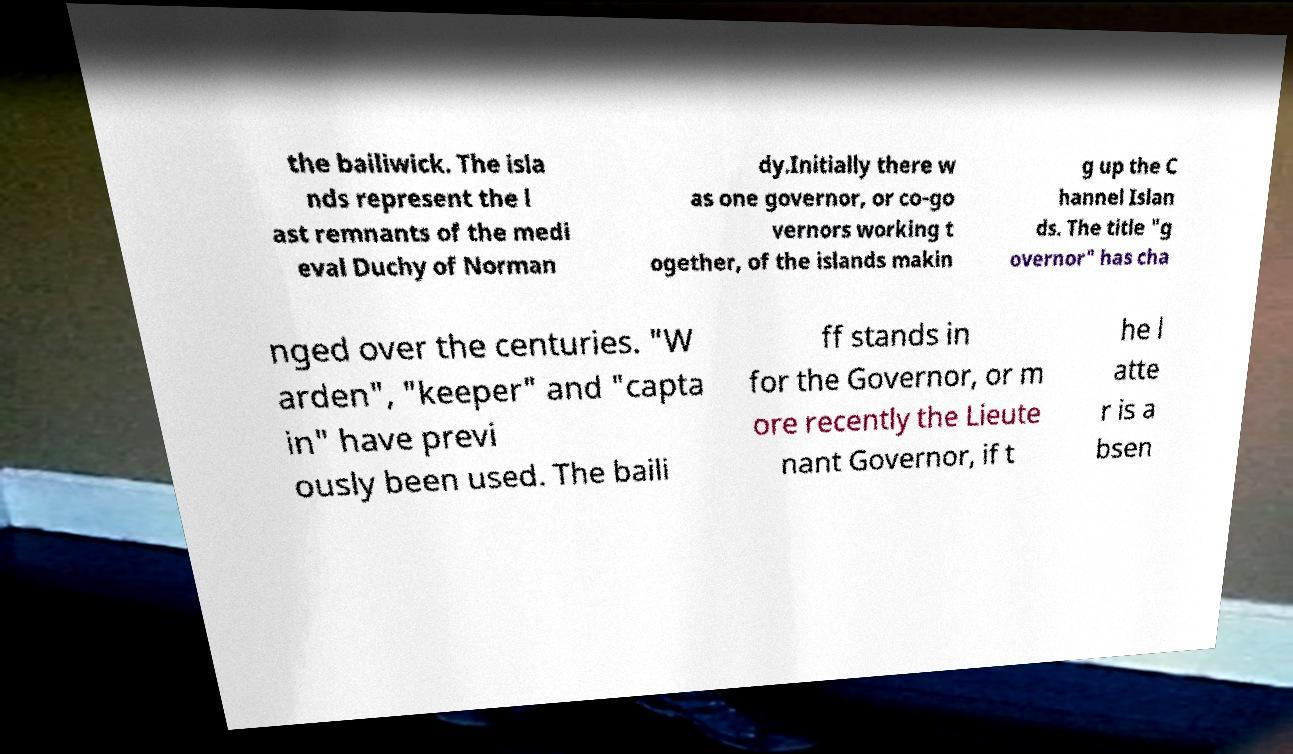Please read and relay the text visible in this image. What does it say? the bailiwick. The isla nds represent the l ast remnants of the medi eval Duchy of Norman dy.Initially there w as one governor, or co-go vernors working t ogether, of the islands makin g up the C hannel Islan ds. The title "g overnor" has cha nged over the centuries. "W arden", "keeper" and "capta in" have previ ously been used. The baili ff stands in for the Governor, or m ore recently the Lieute nant Governor, if t he l atte r is a bsen 